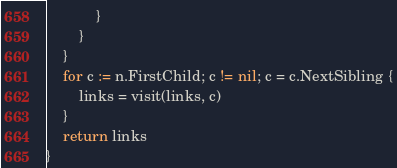<code> <loc_0><loc_0><loc_500><loc_500><_Go_>			}
		}
	}
	for c := n.FirstChild; c != nil; c = c.NextSibling {
		links = visit(links, c)
	}
	return links
}
</code> 